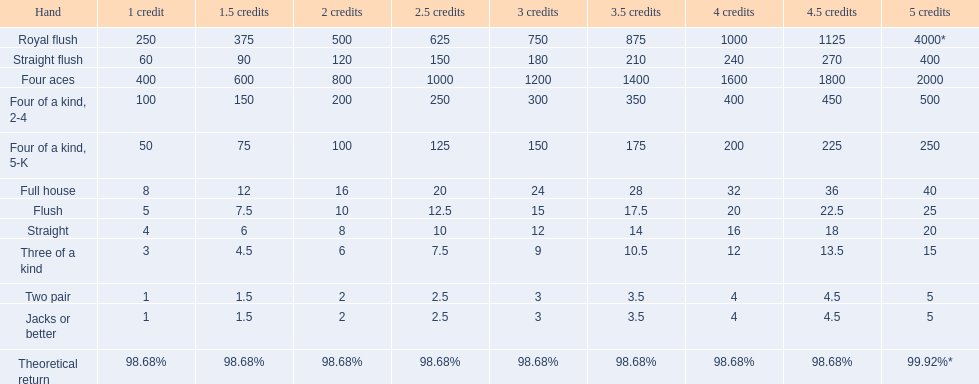What is the values in the 5 credits area? 4000*, 400, 2000, 500, 250, 40, 25, 20, 15, 5, 5. Which of these is for a four of a kind? 500, 250. What is the higher value? 500. What hand is this for Four of a kind, 2-4. 